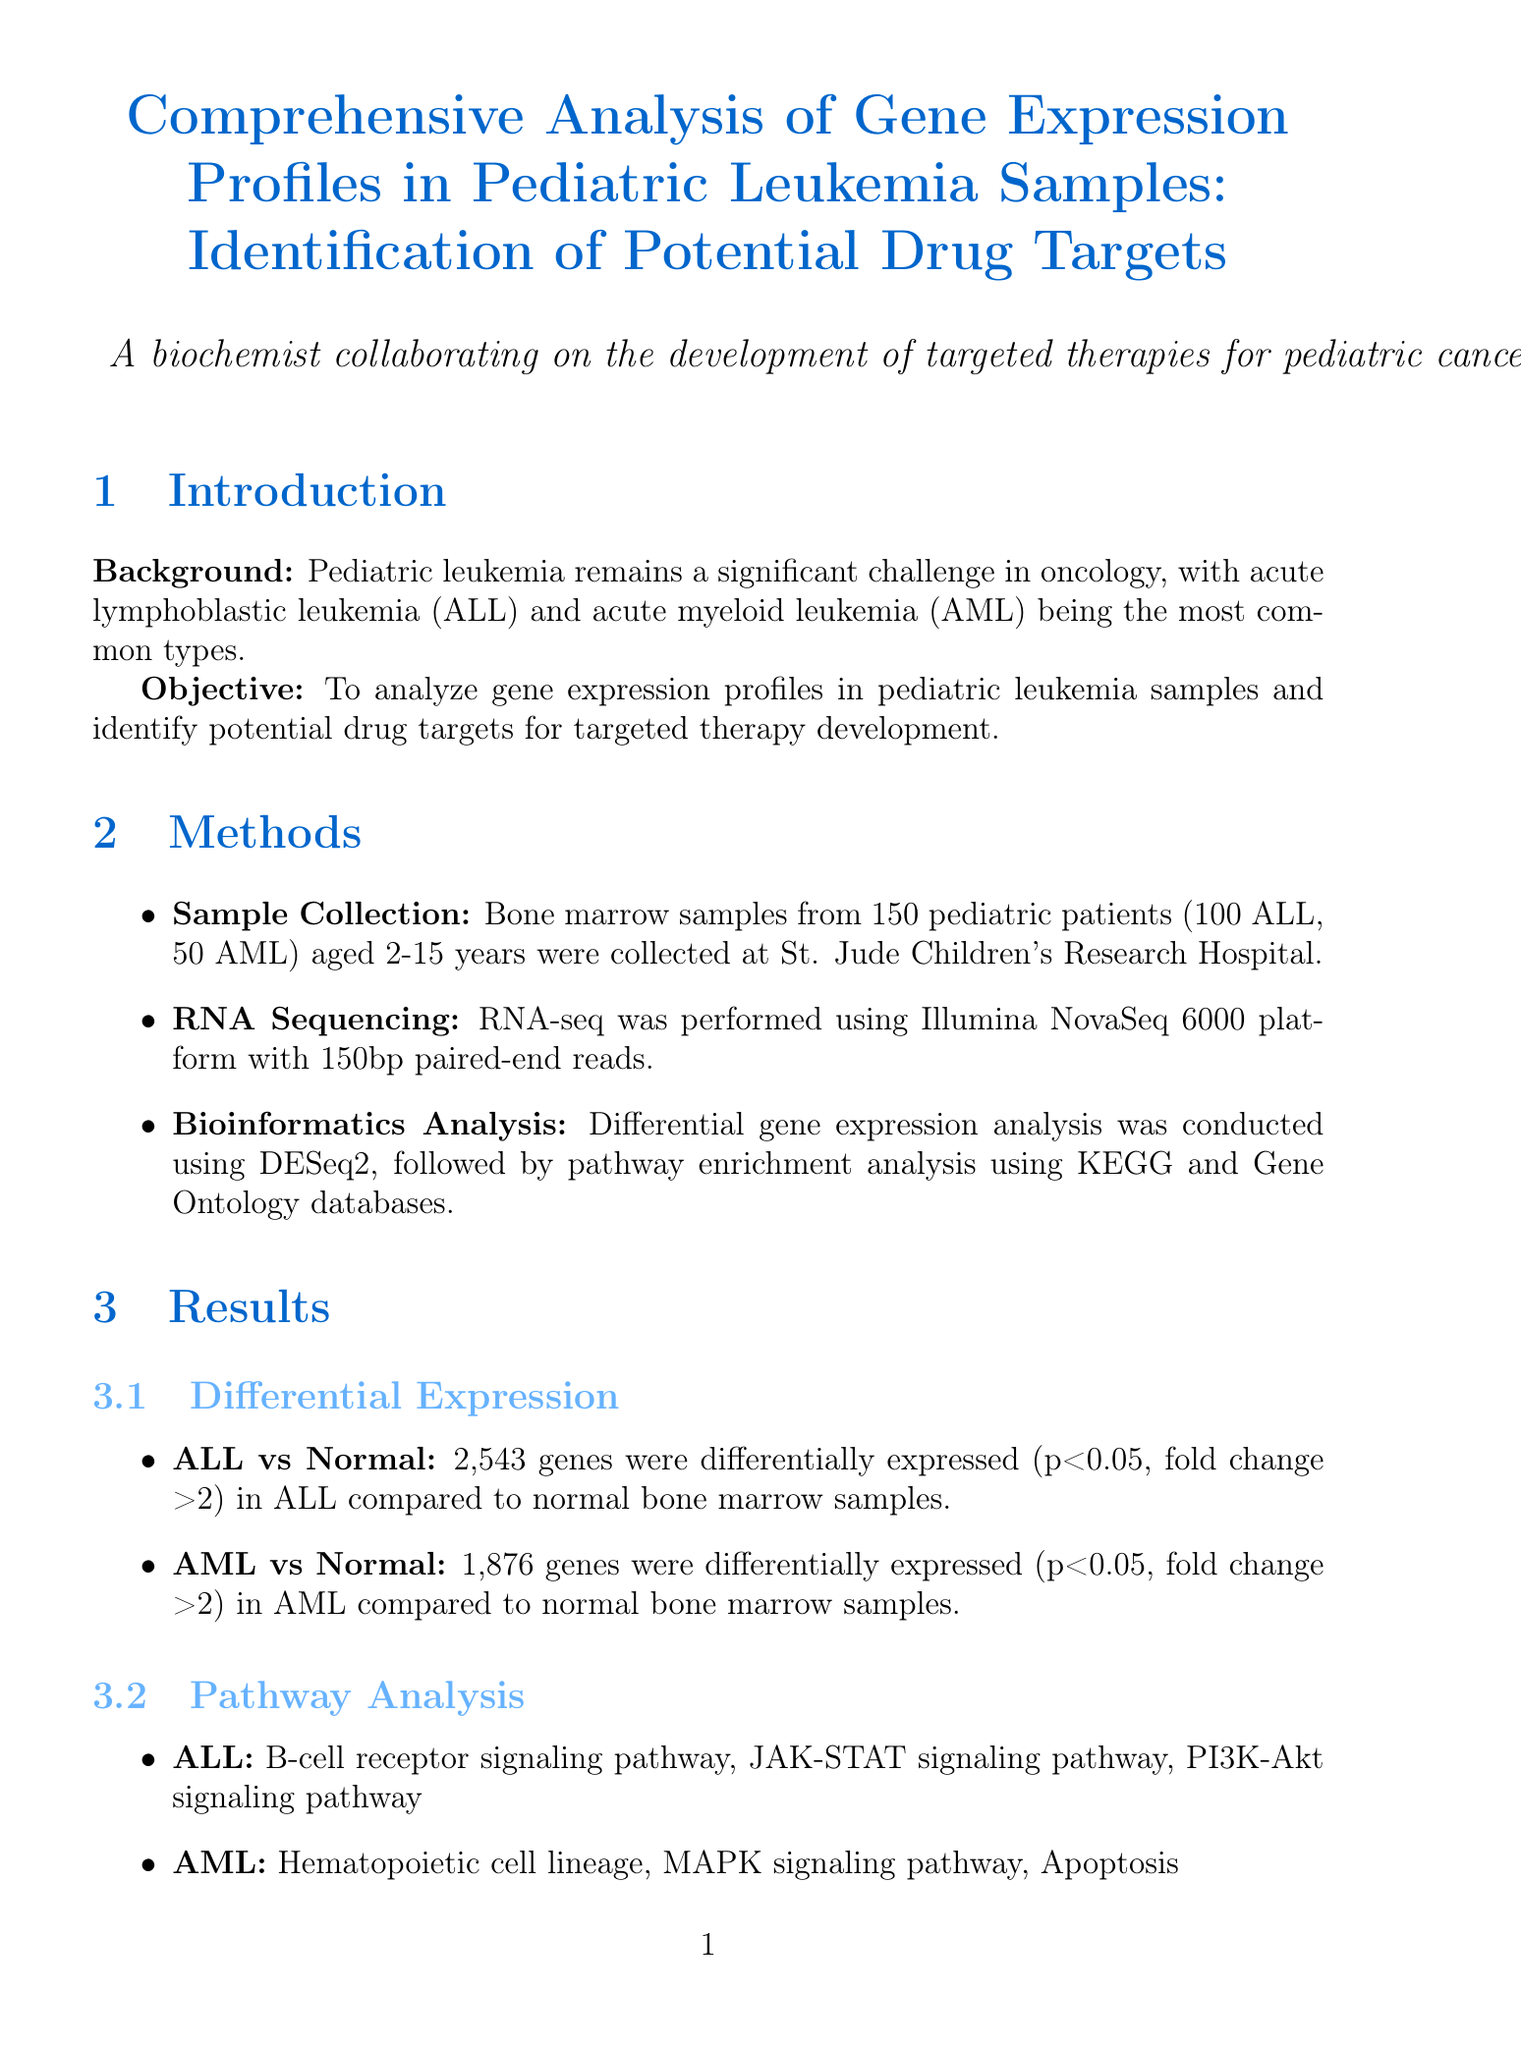What are the two most common types of pediatric leukemia? The introduction of the document specifies that acute lymphoblastic leukemia (ALL) and acute myeloid leukemia (AML) are the most common types of pediatric leukemia.
Answer: ALL and AML How many pediatric patients' samples were analyzed in total? The methods section mentions that bone marrow samples from 150 pediatric patients were collected.
Answer: 150 What are the existing drugs for the gene FLT3? The potential drug targets section lists Midostaurin and Gilteritinib as existing drugs for FLT3.
Answer: Midostaurin, Gilteritinib What was the fold change threshold used for differential expression analysis? The results section indicates that the fold change threshold for differential expression analysis was greater than 2.
Answer: >2 Which signaling pathway is associated with AML? The pathway analysis section lists the MAPK signaling pathway as one of the pathways associated with AML.
Answer: MAPK signaling pathway What potential drug target is overexpressed in 95% of B-ALL samples? The potential drug targets section mentions CD19 as being overexpressed in 95% of B-ALL samples.
Answer: CD19 How many genes were differentially expressed in ALL compared to normal samples? The results section states that 2,543 genes were differentially expressed in ALL compared to normal bone marrow samples.
Answer: 2,543 What is a proposed future direction for the research? The discussion section suggests functional validation of identified targets using CRISPR-Cas9 gene editing as a future direction for the research.
Answer: Functional validation using CRISPR-Cas9 